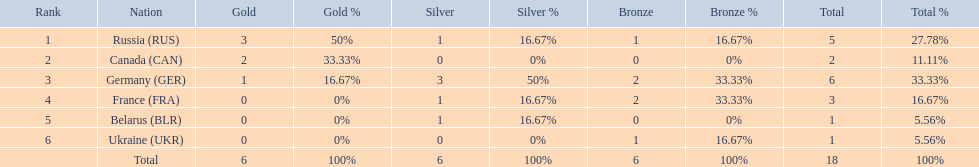Which countries received gold medals? Russia (RUS), Canada (CAN), Germany (GER). Of these countries, which did not receive a silver medal? Canada (CAN). 